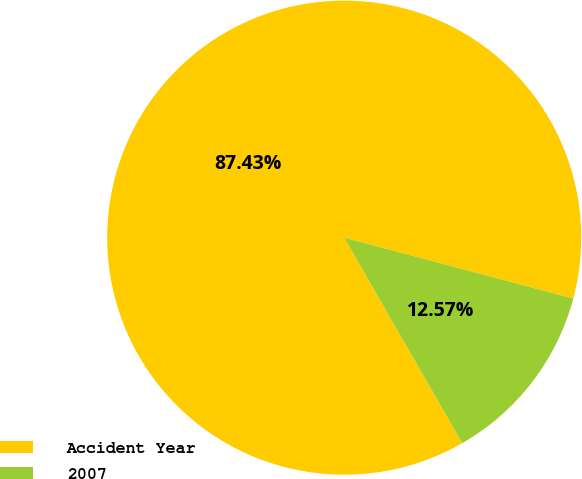Convert chart. <chart><loc_0><loc_0><loc_500><loc_500><pie_chart><fcel>Accident Year<fcel>2007<nl><fcel>87.43%<fcel>12.57%<nl></chart> 